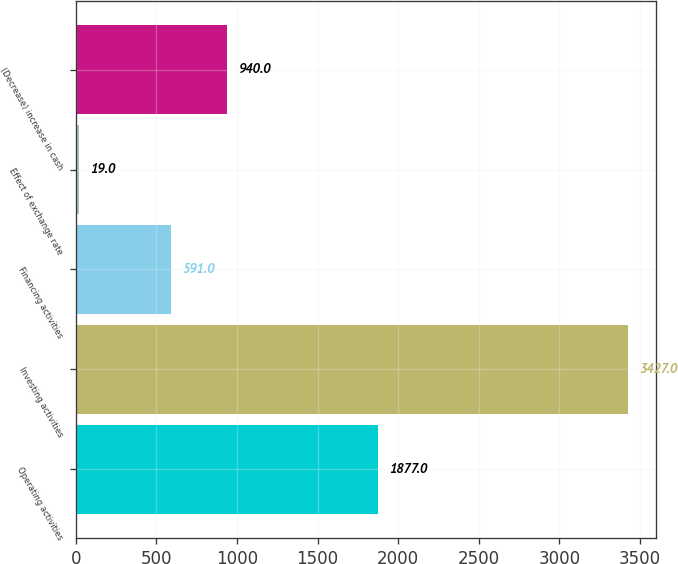Convert chart to OTSL. <chart><loc_0><loc_0><loc_500><loc_500><bar_chart><fcel>Operating activities<fcel>Investing activities<fcel>Financing activities<fcel>Effect of exchange rate<fcel>(Decrease) increase in cash<nl><fcel>1877<fcel>3427<fcel>591<fcel>19<fcel>940<nl></chart> 